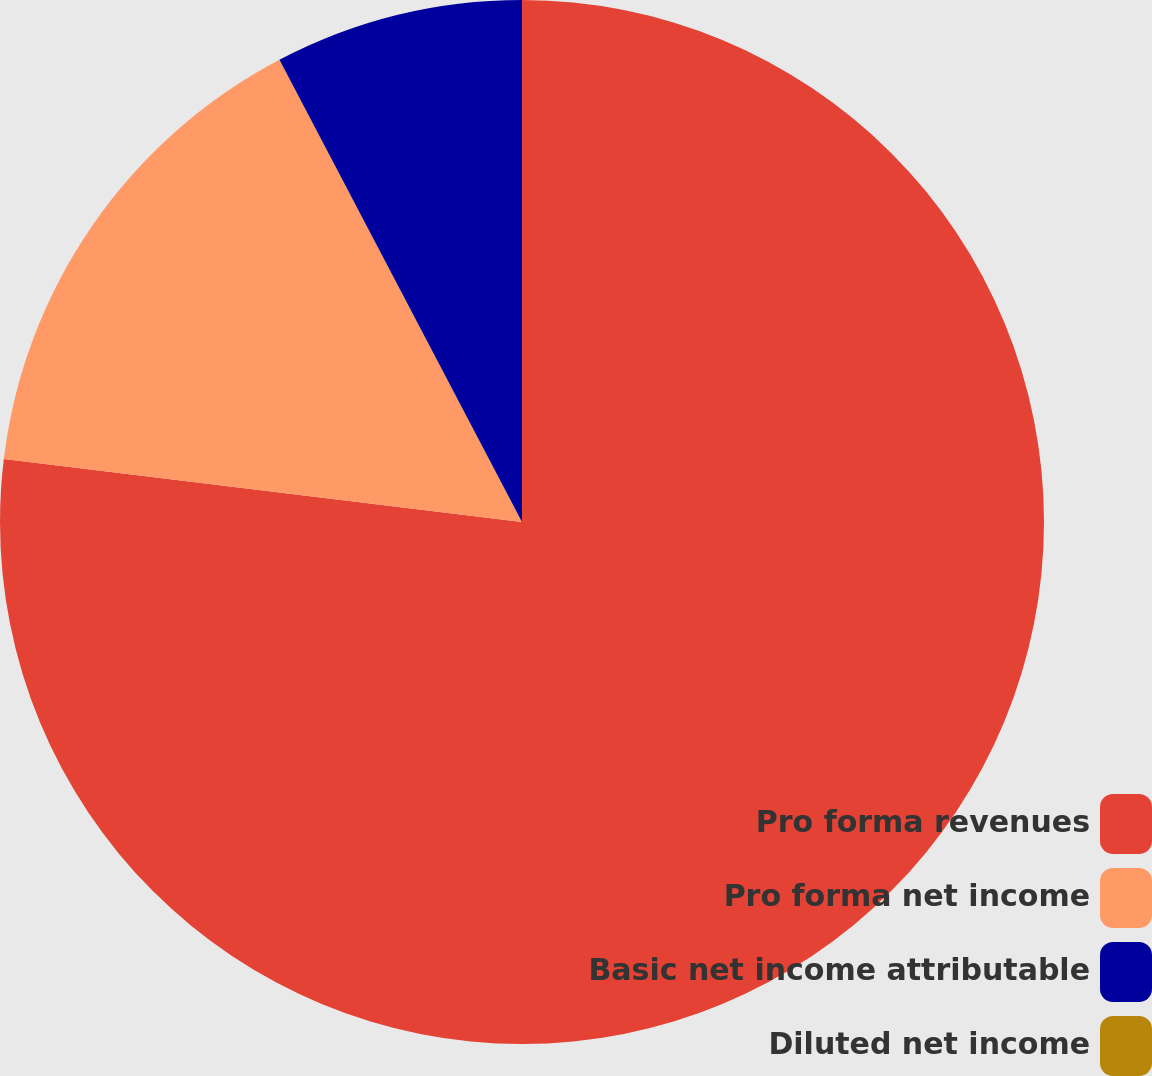<chart> <loc_0><loc_0><loc_500><loc_500><pie_chart><fcel>Pro forma revenues<fcel>Pro forma net income<fcel>Basic net income attributable<fcel>Diluted net income<nl><fcel>76.92%<fcel>15.38%<fcel>7.69%<fcel>0.0%<nl></chart> 